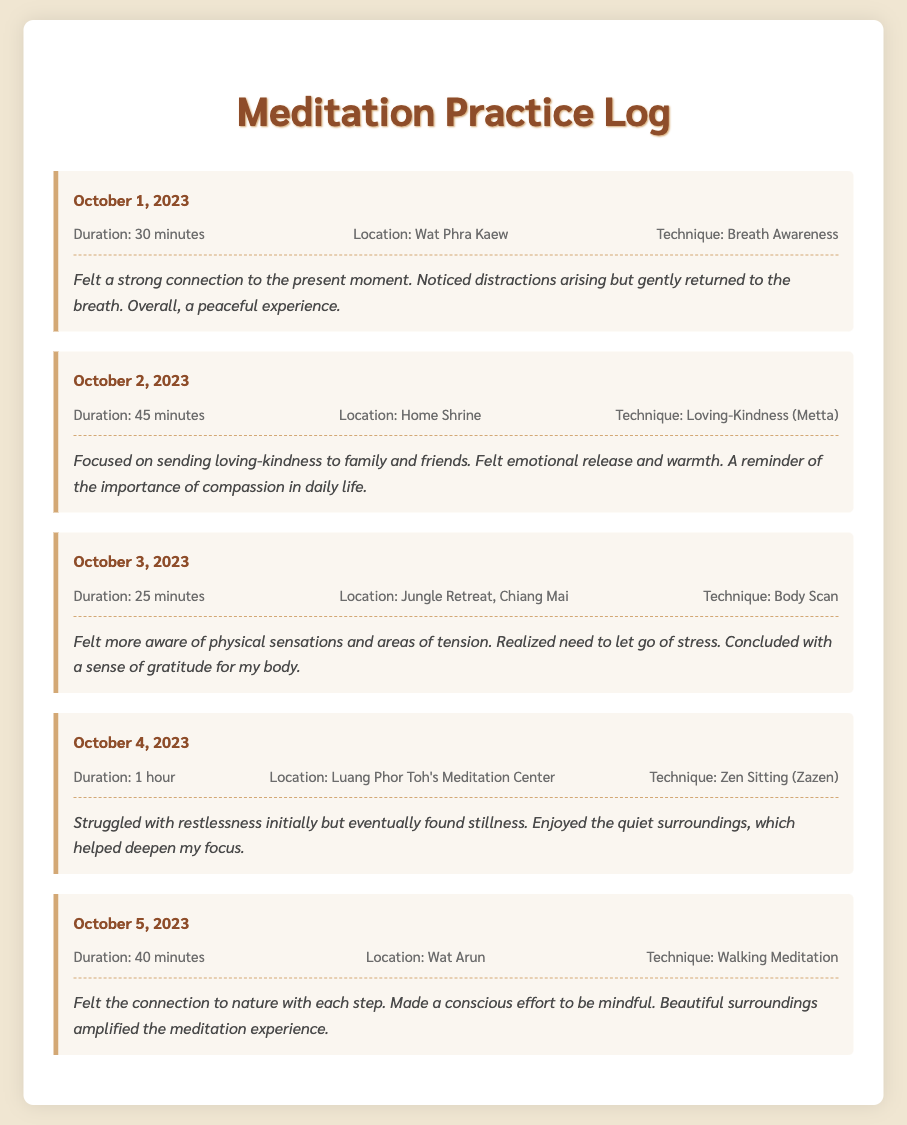What date was the first meditation practice logged? The first meditation practice is logged on October 1, 2023.
Answer: October 1, 2023 What technique was used on October 2, 2023? The technique used on October 2, 2023, is Loving-Kindness (Metta).
Answer: Loving-Kindness (Metta) How long was the meditation session on October 4, 2023? The duration of the meditation session on October 4, 2023, was 1 hour.
Answer: 1 hour What location was used for the meditation on October 5, 2023? The location for the meditation on October 5, 2023, was Wat Arun.
Answer: Wat Arun Which technique helped deepen focus at Luang Phor Toh's Meditation Center? The technique that helped deepen focus at Luang Phor Toh's Meditation Center is Zen Sitting (Zazen).
Answer: Zen Sitting (Zazen) What emotional response was felt during the October 2, 2023, session? The emotional response felt during the October 2 session was warmth and emotional release.
Answer: Warmth and emotional release What was the primary focus during the meditation on October 3, 2023? The primary focus during the meditation on October 3, 2023, was awareness of physical sensations.
Answer: Awareness of physical sensations What did the practitioner feel connected to during the walking meditation? The practitioner felt connected to nature during the walking meditation.
Answer: Nature 